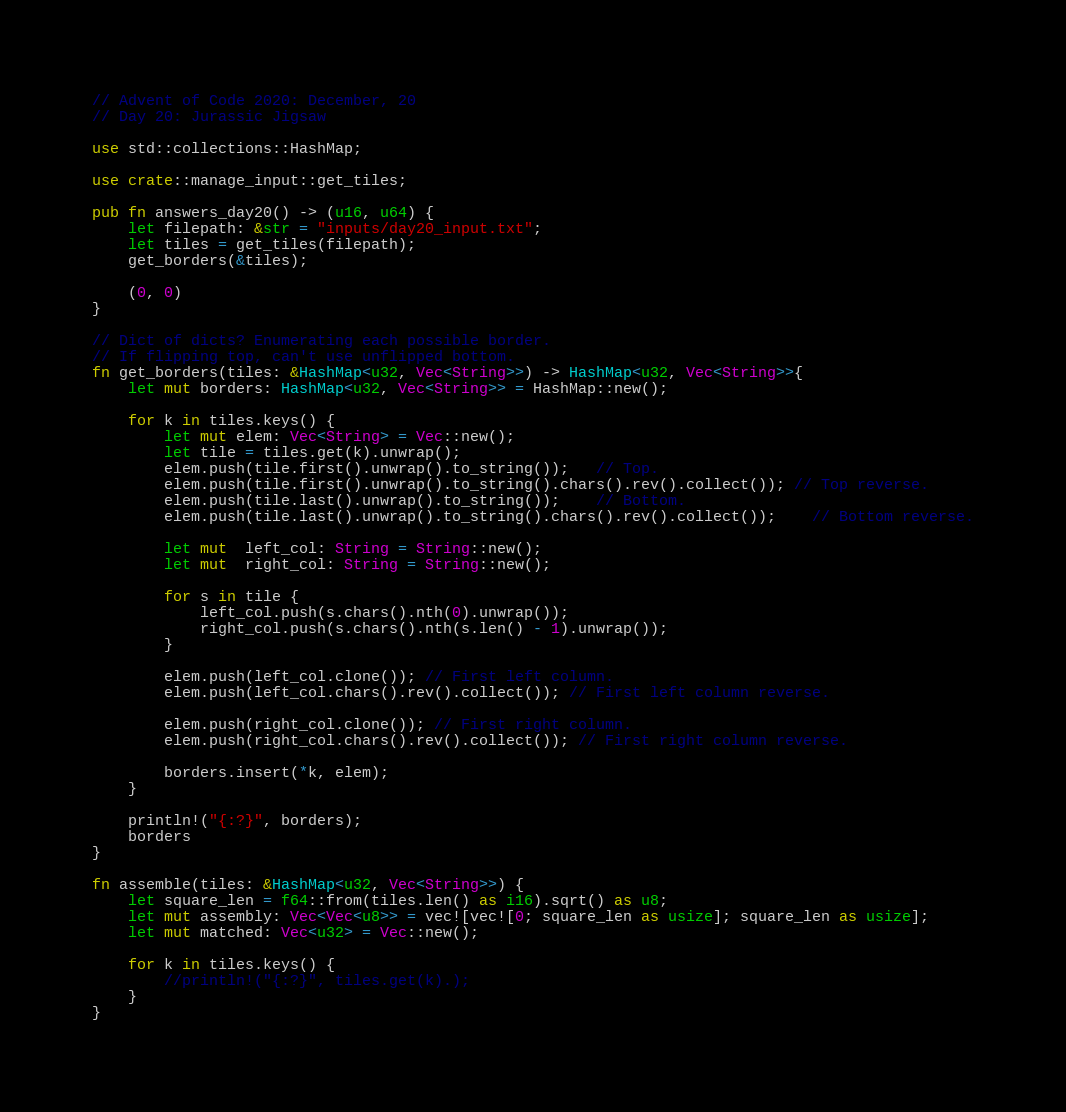Convert code to text. <code><loc_0><loc_0><loc_500><loc_500><_Rust_>// Advent of Code 2020: December, 20
// Day 20: Jurassic Jigsaw

use std::collections::HashMap;

use crate::manage_input::get_tiles;

pub fn answers_day20() -> (u16, u64) {
    let filepath: &str = "inputs/day20_input.txt";
    let tiles = get_tiles(filepath);
    get_borders(&tiles);
    
    (0, 0)
}

// Dict of dicts? Enumerating each possible border.
// If flipping top, can't use unflipped bottom.
fn get_borders(tiles: &HashMap<u32, Vec<String>>) -> HashMap<u32, Vec<String>>{
    let mut borders: HashMap<u32, Vec<String>> = HashMap::new();

    for k in tiles.keys() {
        let mut elem: Vec<String> = Vec::new();
        let tile = tiles.get(k).unwrap();
        elem.push(tile.first().unwrap().to_string());   // Top.
        elem.push(tile.first().unwrap().to_string().chars().rev().collect()); // Top reverse.
        elem.push(tile.last().unwrap().to_string());    // Bottom.
        elem.push(tile.last().unwrap().to_string().chars().rev().collect());    // Bottom reverse.

        let mut  left_col: String = String::new();
        let mut  right_col: String = String::new();

        for s in tile {
            left_col.push(s.chars().nth(0).unwrap());
            right_col.push(s.chars().nth(s.len() - 1).unwrap());
        }

        elem.push(left_col.clone()); // First left column.
        elem.push(left_col.chars().rev().collect()); // First left column reverse.

        elem.push(right_col.clone()); // First right column.
        elem.push(right_col.chars().rev().collect()); // First right column reverse.

        borders.insert(*k, elem);
    }

    println!("{:?}", borders);
    borders
}

fn assemble(tiles: &HashMap<u32, Vec<String>>) {
    let square_len = f64::from(tiles.len() as i16).sqrt() as u8;
    let mut assembly: Vec<Vec<u8>> = vec![vec![0; square_len as usize]; square_len as usize];
    let mut matched: Vec<u32> = Vec::new();

    for k in tiles.keys() {
        //println!("{:?}", tiles.get(k).);
    }
}
</code> 